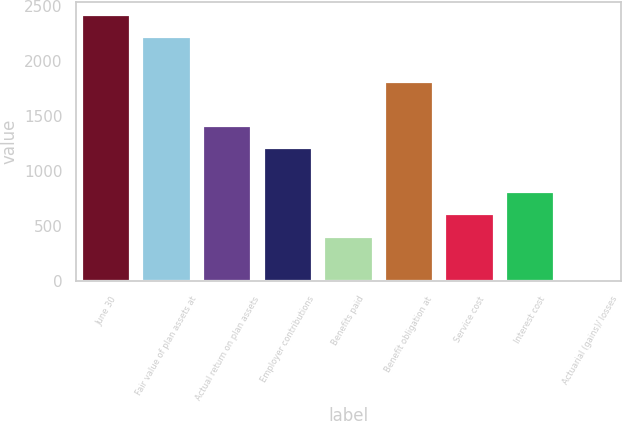Convert chart to OTSL. <chart><loc_0><loc_0><loc_500><loc_500><bar_chart><fcel>June 30<fcel>Fair value of plan assets at<fcel>Actual return on plan assets<fcel>Employer contributions<fcel>Benefits paid<fcel>Benefit obligation at<fcel>Service cost<fcel>Interest cost<fcel>Actuarial (gains)/ losses<nl><fcel>2412.12<fcel>2211.56<fcel>1409.32<fcel>1208.76<fcel>406.52<fcel>1810.44<fcel>607.08<fcel>807.64<fcel>5.4<nl></chart> 